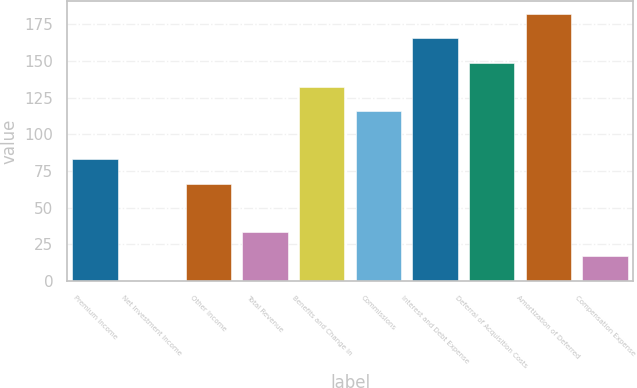Convert chart to OTSL. <chart><loc_0><loc_0><loc_500><loc_500><bar_chart><fcel>Premium Income<fcel>Net Investment Income<fcel>Other Income<fcel>Total Revenue<fcel>Benefits and Change in<fcel>Commissions<fcel>Interest and Debt Expense<fcel>Deferral of Acquisition Costs<fcel>Amortization of Deferred<fcel>Compensation Expense<nl><fcel>82.85<fcel>0.4<fcel>66.36<fcel>33.38<fcel>132.32<fcel>115.83<fcel>165.3<fcel>148.81<fcel>181.79<fcel>16.89<nl></chart> 